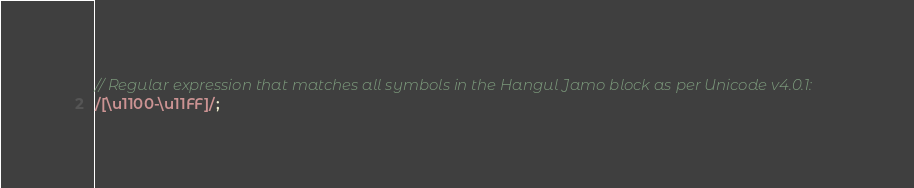<code> <loc_0><loc_0><loc_500><loc_500><_JavaScript_>// Regular expression that matches all symbols in the Hangul Jamo block as per Unicode v4.0.1:
/[\u1100-\u11FF]/;</code> 